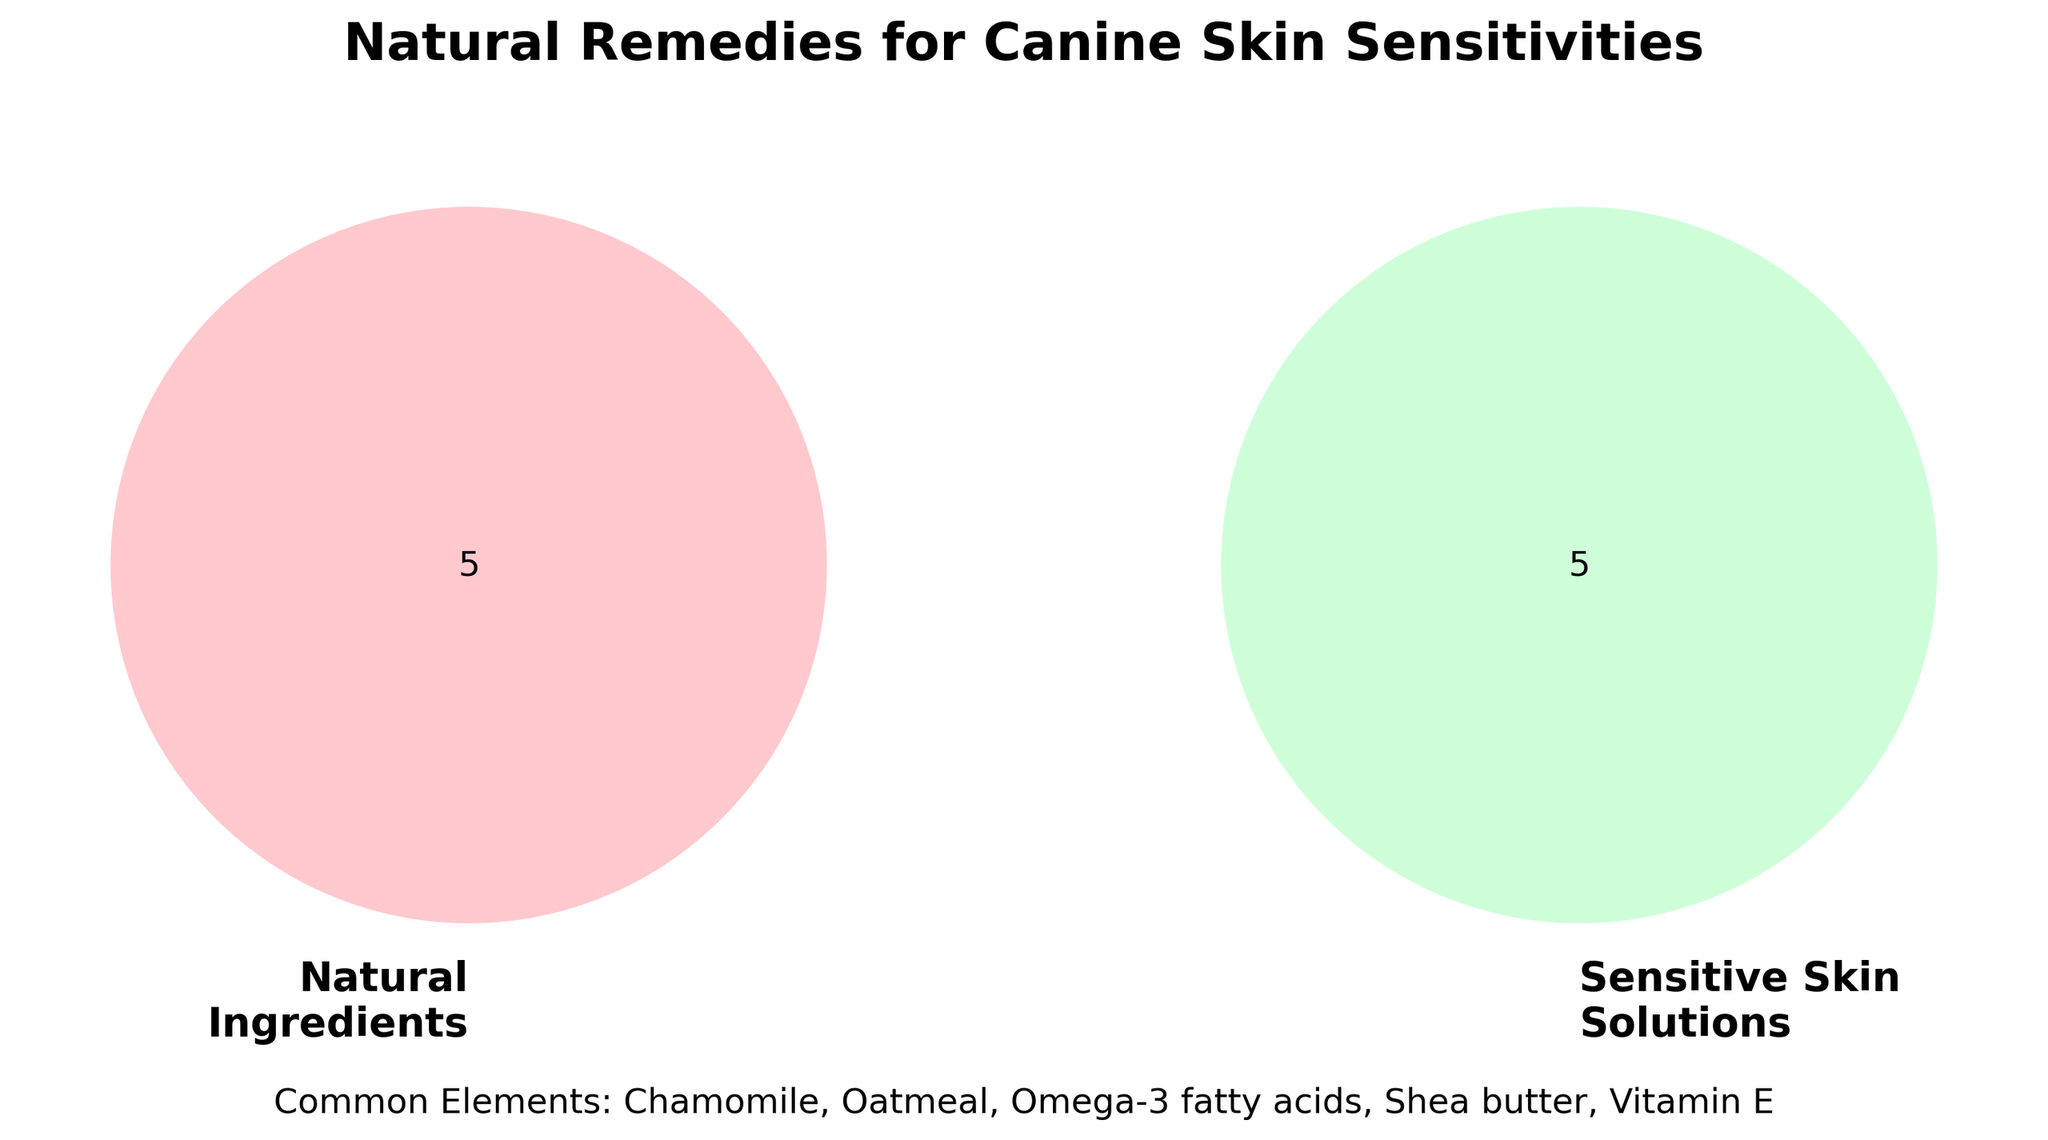What are the groups represented in the Venn Diagram? The Venn Diagram consists of two groups labeled 'Natural Ingredients' and 'Sensitive Skin Solutions'.
Answer: Natural Ingredients, Sensitive Skin Solutions What is the common element between the two groups? The shared elements are listed below the Venn Diagram under "Common Elements".
Answer: Oatmeal, Chamomile, Vitamin E, Shea butter, Omega-3 fatty acids Which natural ingredient is also a sensitive skin solution? An ingredient that appears in the common elements section is both a natural ingredient and sensitive skin solution.
Answer: Oatmeal, Chamomile, Vitamin E, Shea butter, Omega-3 fatty acids How many unique elements are there in the 'Natural Ingredients' group? Count the elements in the 'Natural Ingredients' group that are not in the 'Common Elements'.
Answer: 5 Which set has fewer unique elements, 'Natural Ingredients' or 'Sensitive Skin Solutions'? Compare the number of elements in the 'Natural Ingredients' and 'Sensitive Skin Solutions' sets that are not in the 'Common Elements'.
Answer: Sensitive Skin Solutions Are there more common elements or unique 'Sensitive Skin Solutions'? Compare the number of common elements with the unique elements in the 'Sensitive Skin Solutions' set.
Answer: Common elements What is the total number of distinct remedies listed in the Venn Diagram? Add up the elements in 'Natural Ingredients', 'Sensitive Skin Solutions', and subtract the common elements counted twice.
Answer: 10 Is 'Coconut oil' a common element? Check if 'Coconut oil' is in the common elements section below the Venn Diagram.
Answer: No Which group contains 'Medicated Sprays'? Locate 'Medicated Sprays' in one of the labeled groups.
Answer: Sensitive Skin Solutions How many more unique elements does 'Natural Ingredients' have compared to 'Sensitive Skin Solutions'? Subtract the number of unique 'Sensitive Skin Solutions' elements from 'Natural Ingredients'.
Answer: 1 